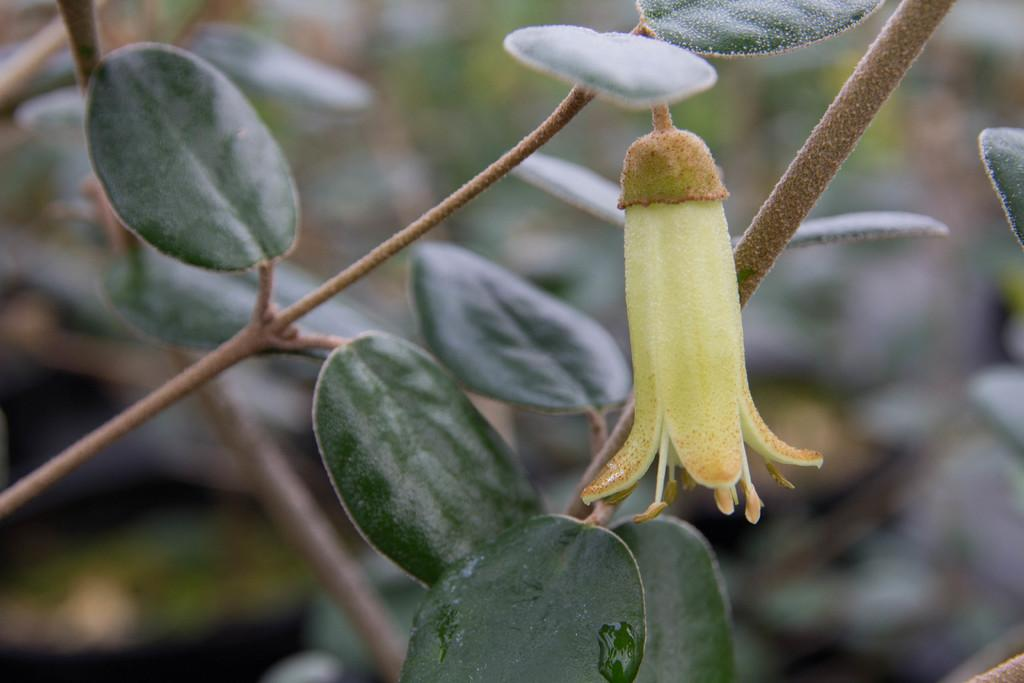What type of plant can be seen in the image? There is a flower in the image. Are there any other plants visible in the image? Yes, there are plants in the image. How would you describe the overall clarity of the image? The image is blurred. What type of sticks can be seen in the image? There are no sticks present in the image. 